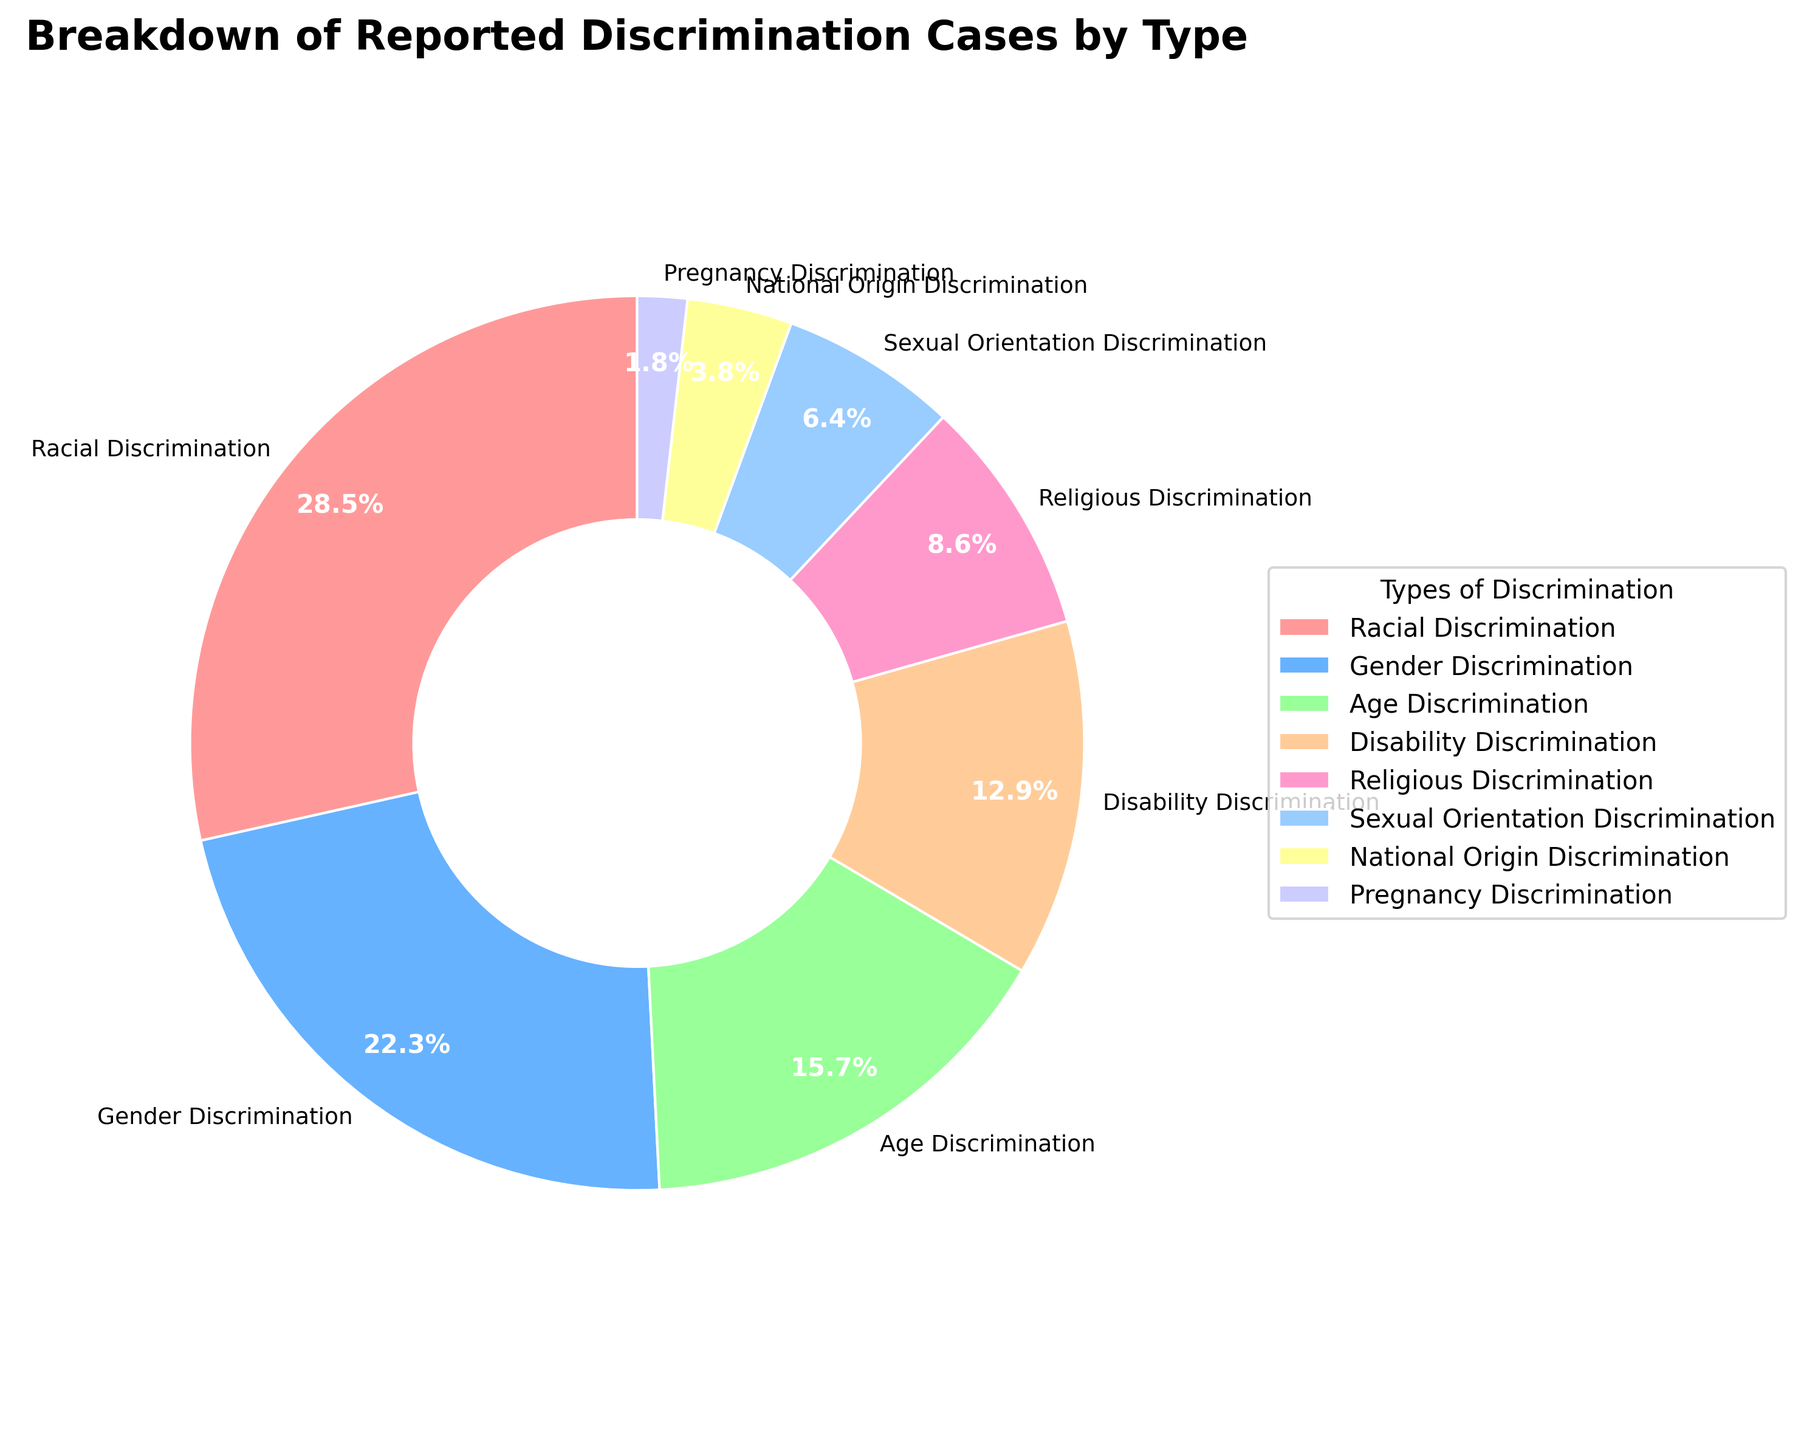Which type of discrimination has the highest percentage of reported cases? Looking at the pie chart, the label with the largest wedge is "Racial Discrimination" with a percentage of 28.5%.
Answer: Racial Discrimination What is the total percentage for Gender Discrimination and Age Discrimination combined? The pie chart shows that Gender Discrimination is 22.3% and Age Discrimination is 15.7%. Adding these percentages, 22.3% + 15.7% = 38%.
Answer: 38% Which type of discrimination has a lower reported percentage: Religious Discrimination or Disability Discrimination? Based on the pie chart, Religious Discrimination is 8.6% and Disability Discrimination is 12.9%. Since 8.6% is less than 12.9%, Religious Discrimination has a lower reported percentage.
Answer: Religious Discrimination How much higher is the percentage of Racial Discrimination compared to Sexual Orientation Discrimination? From the chart, Racial Discrimination is 28.5% and Sexual Orientation Discrimination is 6.4%. Subtracting these percentages, 28.5% - 6.4% = 22.1%.
Answer: 22.1% Which type of discrimination has the smallest wedge in the pie chart? The smallest wedge corresponds to Pregnancy Discrimination, which has a percentage of 1.8%.
Answer: Pregnancy Discrimination What is the difference in percentage between National Origin Discrimination and Age Discrimination? The chart shows National Origin Discrimination at 3.8% and Age Discrimination at 15.7%. The difference is 15.7% - 3.8% = 11.9%.
Answer: 11.9% What proportion of reported cases is accounted for by Gender Discrimination and Racial Discrimination together? Gender Discrimination is 22.3% and Racial Discrimination is 28.5%. Summing these gives 22.3% + 28.5% = 50.8%.
Answer: 50.8% Is the percentage of Disability Discrimination higher or lower than the percentage of Religious Discrimination? Disability Discrimination is 12.9% and Religious Discrimination is 8.6%, so Disability Discrimination is higher.
Answer: Higher By how much does the percentage of Age Discrimination exceed that of National Origin Discrimination? The chart shows Age Discrimination at 15.7% and National Origin Discrimination at 3.8%. The difference is 15.7% - 3.8% = 11.9%.
Answer: 11.9% What’s the sum of percentages for the three least reported types of discrimination? The chart indicates Pregnancy Discrimination (1.8%), National Origin Discrimination (3.8%), and Sexual Orientation Discrimination (6.4%). Summing these gives 1.8% + 3.8% + 6.4% = 12%.
Answer: 12% 